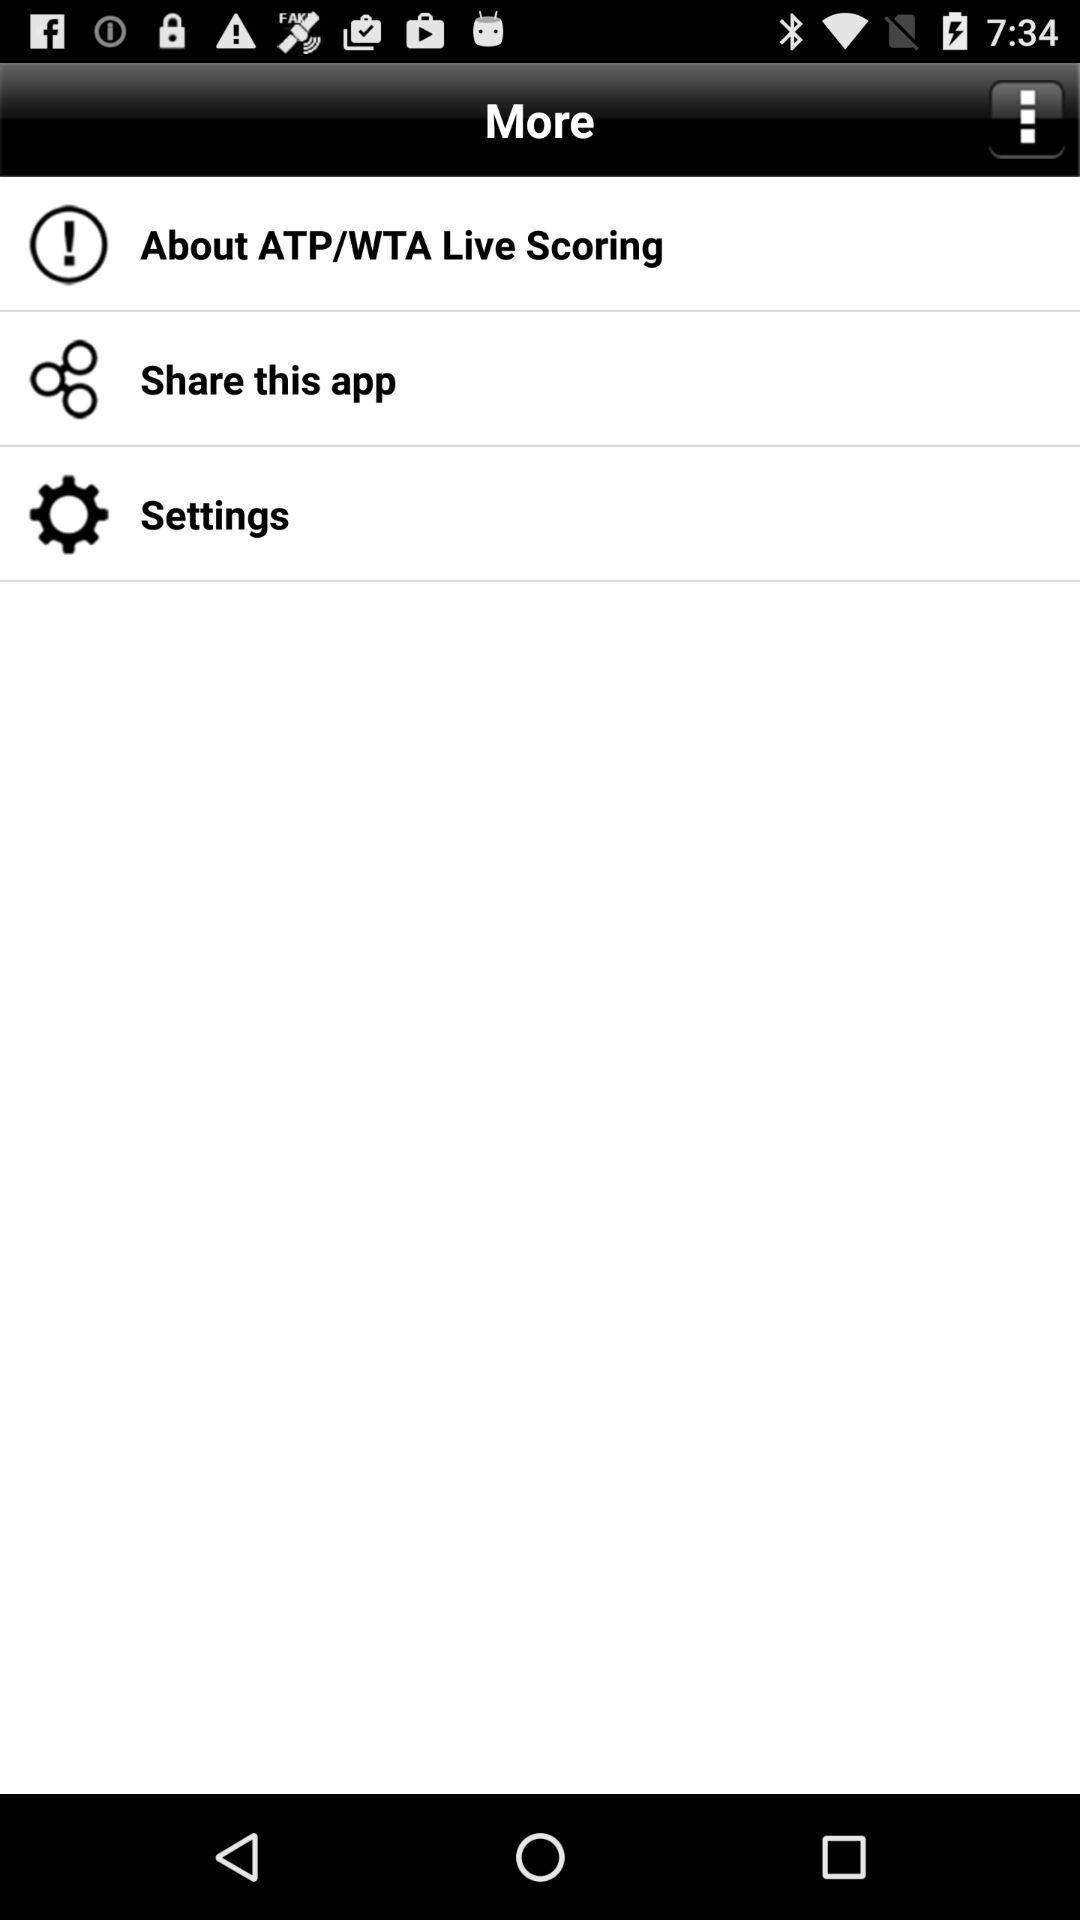What is the name of the application? The name of the application is "ATP/WTA Live Scoring". 